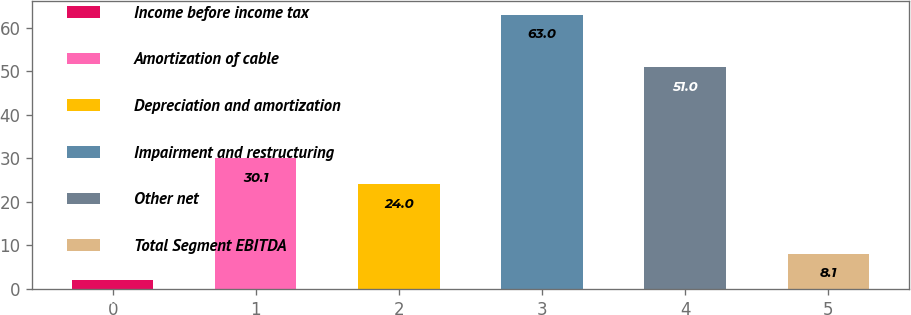<chart> <loc_0><loc_0><loc_500><loc_500><bar_chart><fcel>Income before income tax<fcel>Amortization of cable<fcel>Depreciation and amortization<fcel>Impairment and restructuring<fcel>Other net<fcel>Total Segment EBITDA<nl><fcel>2<fcel>30.1<fcel>24<fcel>63<fcel>51<fcel>8.1<nl></chart> 